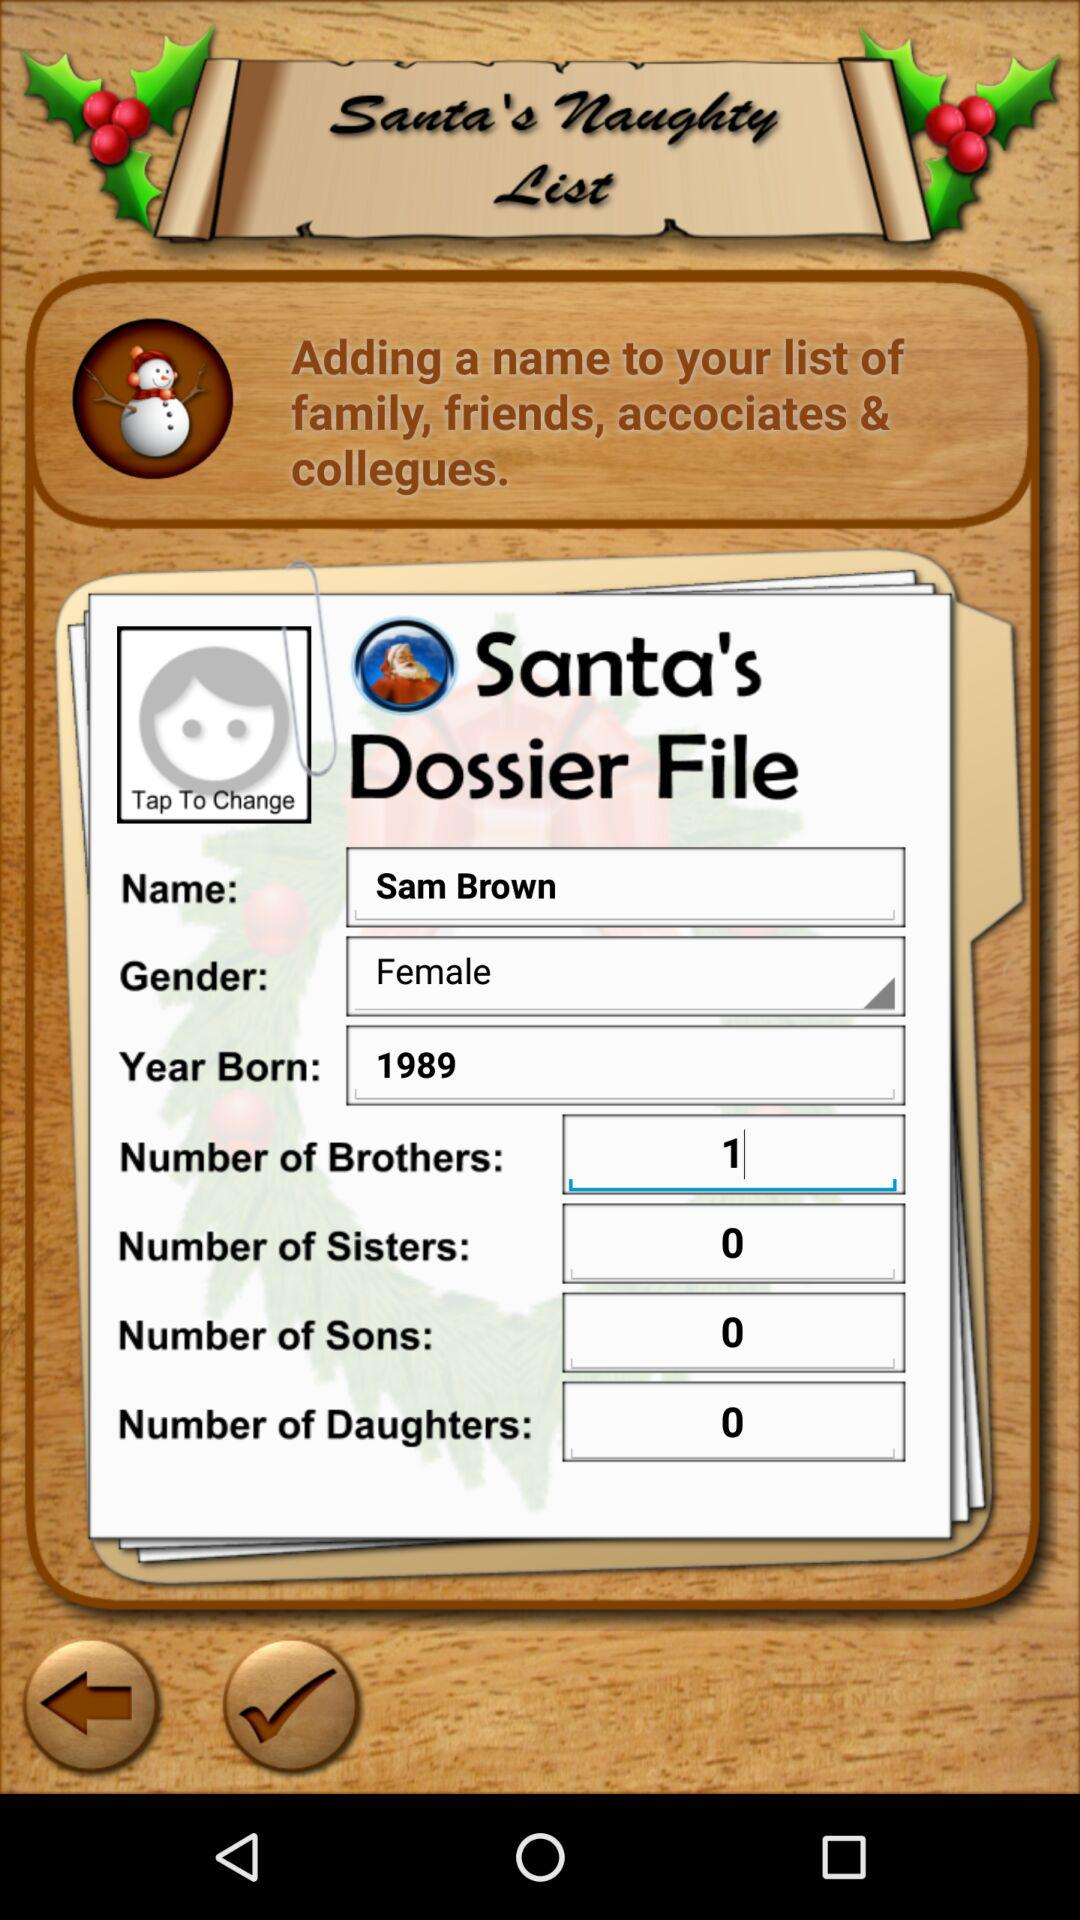What is the number of brothers of the user? The number of brothers of the user is 1. 